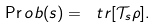Convert formula to latex. <formula><loc_0><loc_0><loc_500><loc_500>\Pr o b ( s ) = \ t r [ \mathcal { T } _ { s } \rho ] .</formula> 